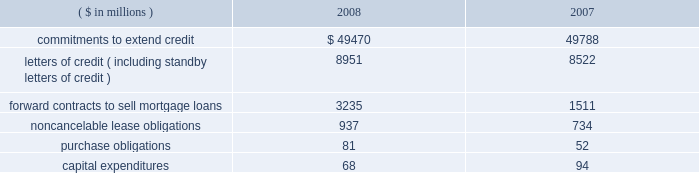Notes to consolidated financial statements fifth third bancorp 81 vii held by the trust vii bear a fixed rate of interest of 8.875% ( 8.875 % ) until may 15 , 2058 .
Thereafter , the notes pay a floating rate at three-month libor plus 500 bp .
The bancorp entered into an interest rate swap to convert $ 275 million of the fixed-rate debt into floating .
At december 31 , 2008 , the rate paid on the swap was 6.05% ( 6.05 % ) .
The jsn vii may be redeemed at the option of the bancorp on or after may 15 , 2013 , or in certain other limited circumstances , at a redemption price of 100% ( 100 % ) of the principal amount plus accrued but unpaid interest .
All redemptions are subject to certain conditions and generally require approval by the federal reserve board .
Subsidiary long-term borrowings the senior fixed-rate bank notes due from 2009 to 2019 are the obligations of a subsidiary bank .
The maturities of the face value of the senior fixed-rate bank notes are as follows : $ 36 million in 2009 , $ 800 million in 2010 and $ 275 million in 2019 .
The bancorp entered into interest rate swaps to convert $ 1.1 billion of the fixed-rate debt into floating rates .
At december 31 , 2008 , the rates paid on these swaps were 2.19% ( 2.19 % ) on $ 800 million and 2.20% ( 2.20 % ) on $ 275 million .
In august 2008 , $ 500 million of senior fixed-rate bank notes issued in july of 2003 matured and were paid .
These long-term bank notes were issued to third-party investors at a fixed rate of 3.375% ( 3.375 % ) .
The senior floating-rate bank notes due in 2013 are the obligations of a subsidiary bank .
The notes pay a floating rate at three-month libor plus 11 bp .
The senior extendable notes consist of $ 797 million that currently pay interest at three-month libor plus 4 bp and $ 400 million that pay at the federal funds open rate plus 12 bp .
The subordinated fixed-rate bank notes due in 2015 are the obligations of a subsidiary bank .
The bancorp entered into interest rate swaps to convert the fixed-rate debt into floating rate .
At december 31 , 2008 , the weighted-average rate paid on the swaps was 3.29% ( 3.29 % ) .
The junior subordinated floating-rate bank notes due in 2032 and 2033 were assumed by a bancorp subsidiary as part of the acquisition of crown in november 2007 .
Two of the notes pay floating at three-month libor plus 310 and 325 bp .
The third note pays floating at six-month libor plus 370 bp .
The three-month libor plus 290 bp and the three-month libor plus 279 bp junior subordinated debentures due in 2033 and 2034 , respectively , were assumed by a subsidiary of the bancorp in connection with the acquisition of first national bank .
The obligations were issued to fnb statutory trusts i and ii , respectively .
The junior subordinated floating-rate bank notes due in 2035 were assumed by a bancorp subsidiary as part of the acquisition of first charter in may 2008 .
The obligations were issued to first charter capital trust i and ii , respectively .
The notes of first charter capital trust i and ii pay floating at three-month libor plus 169 bp and 142 bp , respectively .
The bancorp has fully and unconditionally guaranteed all obligations under the acquired trust preferred securities .
At december 31 , 2008 , fhlb advances have rates ranging from 0% ( 0 % ) to 8.34% ( 8.34 % ) , with interest payable monthly .
The advances are secured by certain residential mortgage loans and securities totaling $ 8.6 billion .
At december 31 , 2008 , $ 2.5 billion of fhlb advances are floating rate .
The bancorp has interest rate caps , with a notional of $ 1.5 billion , held against its fhlb advance borrowings .
The $ 3.6 billion in advances mature as follows : $ 1.5 billion in 2009 , $ 1 million in 2010 , $ 2 million in 2011 , $ 1 billion in 2012 and $ 1.1 billion in 2013 and thereafter .
Medium-term senior notes and subordinated bank notes with maturities ranging from one year to 30 years can be issued by two subsidiary banks , of which $ 3.8 billion was outstanding at december 31 , 2008 with $ 16.2 billion available for future issuance .
There were no other medium-term senior notes outstanding on either of the two subsidiary banks as of december 31 , 2008 .
15 .
Commitments , contingent liabilities and guarantees the bancorp , in the normal course of business , enters into financial instruments and various agreements to meet the financing needs of its customers .
The bancorp also enters into certain transactions and agreements to manage its interest rate and prepayment risks , provide funding , equipment and locations for its operations and invest in its communities .
These instruments and agreements involve , to varying degrees , elements of credit risk , counterparty risk and market risk in excess of the amounts recognized in the bancorp 2019s consolidated balance sheets .
Creditworthiness for all instruments and agreements is evaluated on a case-by-case basis in accordance with the bancorp 2019s credit policies .
The bancorp 2019s significant commitments , contingent liabilities and guarantees in excess of the amounts recognized in the consolidated balance sheets are summarized as follows : commitments the bancorp has certain commitments to make future payments under contracts .
A summary of significant commitments at december 31: .
Commitments to extend credit are agreements to lend , typically having fixed expiration dates or other termination clauses that may require payment of a fee .
Since many of the commitments to extend credit may expire without being drawn upon , the total commitment amounts do not necessarily represent future cash flow requirements .
The bancorp is exposed to credit risk in the event of nonperformance for the amount of the contract .
Fixed-rate commitments are also subject to market risk resulting from fluctuations in interest rates and the bancorp 2019s exposure is limited to the replacement value of those commitments .
As of december 31 , 2008 and 2007 , the bancorp had a reserve for unfunded commitments totaling $ 195 million and $ 95 million , respectively , included in other liabilities in the consolidated balance sheets .
Standby and commercial letters of credit are conditional commitments issued to guarantee the performance of a customer to a third party .
At december 31 , 2008 , approximately $ 3.3 billion of letters of credit expire within one year ( including $ 57 million issued on behalf of commercial customers to facilitate trade payments in dollars and foreign currencies ) , $ 5.3 billion expire between one to five years and $ 0.4 billion expire thereafter .
Standby letters of credit are considered guarantees in accordance with fasb interpretation no .
45 , 201cguarantor 2019s accounting and disclosure requirements for guarantees , including indirect guarantees of indebtedness of others 201d ( fin 45 ) .
At december 31 , 2008 , the reserve related to these standby letters of credit was $ 3 million .
Approximately 66% ( 66 % ) and 70% ( 70 % ) of the total standby letters of credit were secured as of december 31 , 2008 and 2007 , respectively .
In the event of nonperformance by the customers , the bancorp has rights to the underlying collateral , which can include commercial real estate , physical plant and property , inventory , receivables , cash and marketable securities .
The bancorp monitors the credit risk associated with the standby letters of credit using the same dual risk rating system utilized for .
What was the average securitization rate of standby letters of credit as of december 2008 and 2007? 
Computations: ((66% + 70%) / 2)
Answer: 0.68. 